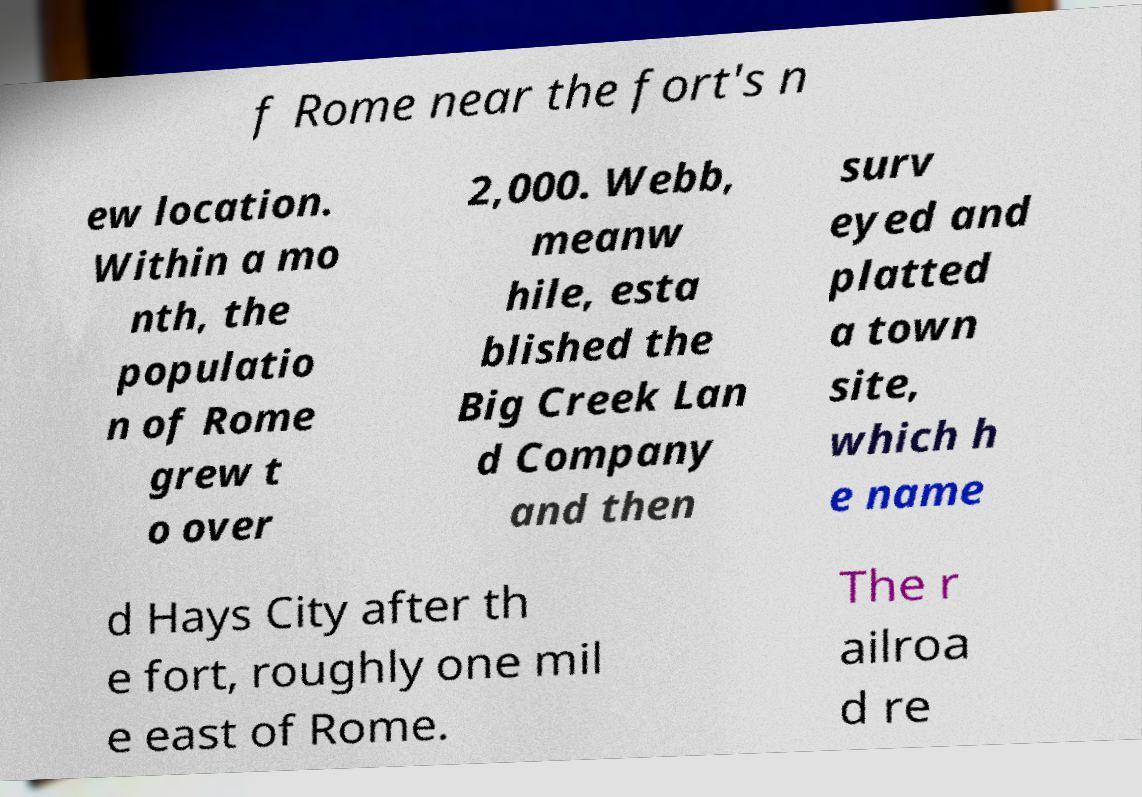Please identify and transcribe the text found in this image. f Rome near the fort's n ew location. Within a mo nth, the populatio n of Rome grew t o over 2,000. Webb, meanw hile, esta blished the Big Creek Lan d Company and then surv eyed and platted a town site, which h e name d Hays City after th e fort, roughly one mil e east of Rome. The r ailroa d re 